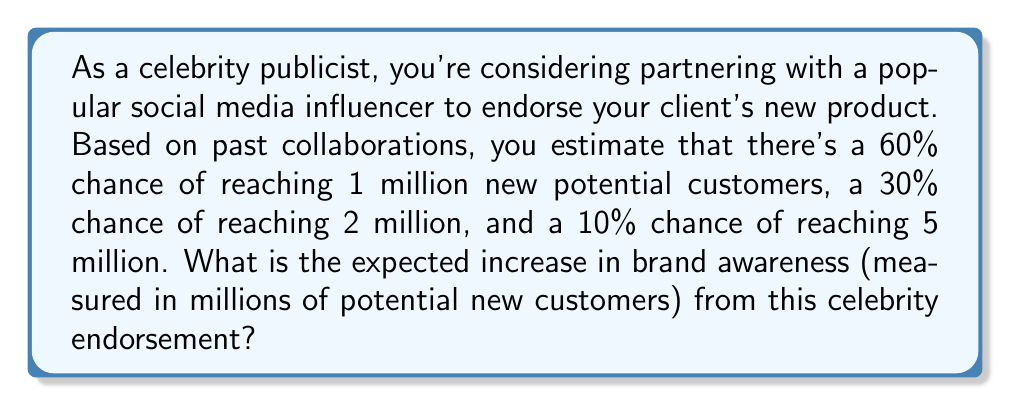Give your solution to this math problem. To solve this expected value problem, we need to follow these steps:

1. Identify the possible outcomes and their probabilities:
   - 1 million new customers with 60% probability
   - 2 million new customers with 30% probability
   - 5 million new customers with 10% probability

2. Calculate the expected value using the formula:
   $$ E(X) = \sum_{i=1}^n x_i \cdot p(x_i) $$
   where $x_i$ are the possible outcomes and $p(x_i)$ are their respective probabilities.

3. Plug in the values:
   $$ E(X) = (1 \cdot 0.60) + (2 \cdot 0.30) + (5 \cdot 0.10) $$

4. Perform the calculations:
   $$ E(X) = 0.60 + 0.60 + 0.50 = 1.70 $$

Therefore, the expected increase in brand awareness is 1.70 million potential new customers.
Answer: 1.70 million 